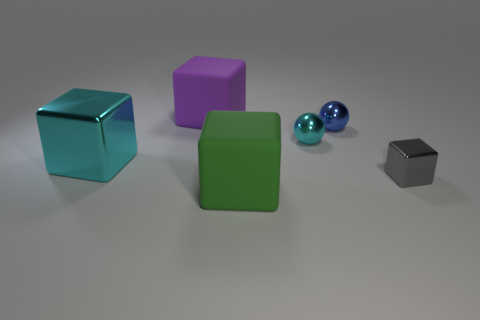There is a big metal block; is its color the same as the cube behind the tiny cyan ball?
Your response must be concise. No. How many metal balls are the same size as the blue shiny thing?
Your answer should be compact. 1. Does the rubber object in front of the small blue ball have the same shape as the big matte object that is behind the gray block?
Your answer should be very brief. Yes. What material is the cyan thing to the left of the matte thing on the right side of the big matte object that is on the left side of the large green object made of?
Make the answer very short. Metal. There is a green object that is the same size as the cyan cube; what is its shape?
Offer a very short reply. Cube. Is there a big cube that has the same color as the large shiny thing?
Offer a very short reply. No. What is the size of the green matte thing?
Give a very brief answer. Large. Do the gray block and the green object have the same material?
Give a very brief answer. No. What number of large blocks are to the left of the small gray shiny block that is right of the small sphere that is in front of the small blue object?
Make the answer very short. 3. The metallic object behind the small cyan shiny sphere has what shape?
Your response must be concise. Sphere. 